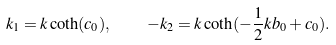<formula> <loc_0><loc_0><loc_500><loc_500>k _ { 1 } = k \coth ( c _ { 0 } ) , \quad - k _ { 2 } = k \coth ( - \frac { 1 } { 2 } k b _ { 0 } + c _ { 0 } ) .</formula> 